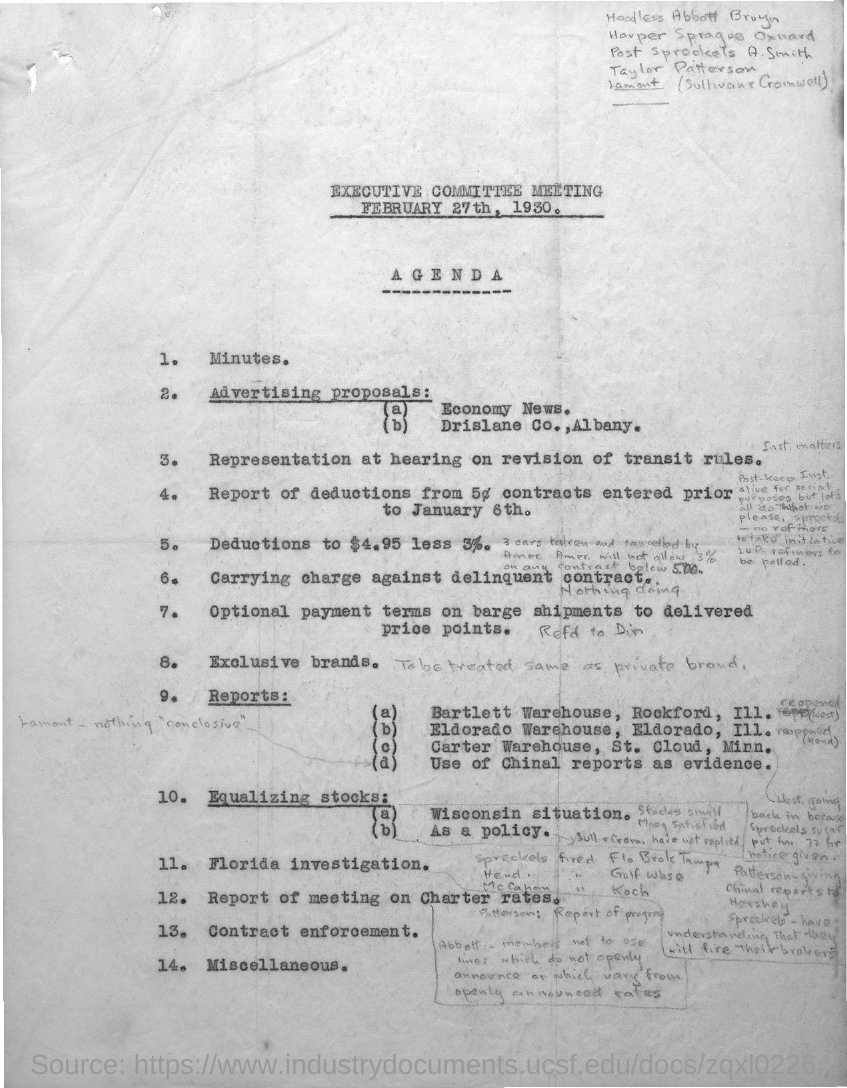What is the date of the meeting?
Your response must be concise. February 27th, 1930. 